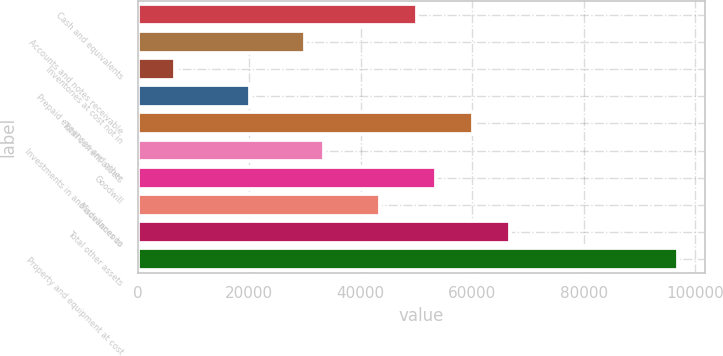<chart> <loc_0><loc_0><loc_500><loc_500><bar_chart><fcel>Cash and equivalents<fcel>Accounts and notes receivable<fcel>Inventories at cost not in<fcel>Prepaid expenses and other<fcel>Total current assets<fcel>Investments in and advances to<fcel>Goodwill<fcel>Miscellaneous<fcel>Total other assets<fcel>Property and equipment at cost<nl><fcel>50152.4<fcel>30098.1<fcel>6701.38<fcel>20070.9<fcel>60179.6<fcel>33440.5<fcel>53494.8<fcel>43467.7<fcel>66864.4<fcel>96945.9<nl></chart> 